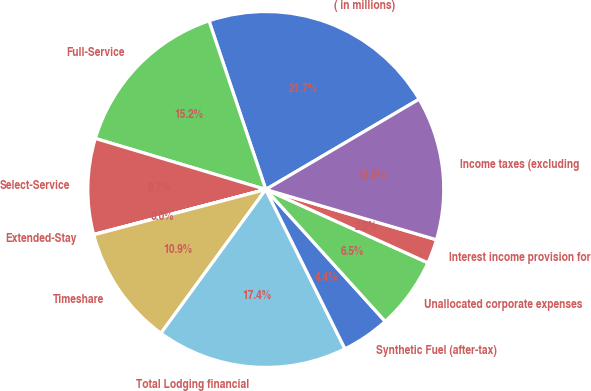Convert chart. <chart><loc_0><loc_0><loc_500><loc_500><pie_chart><fcel>( in millions)<fcel>Full-Service<fcel>Select-Service<fcel>Extended-Stay<fcel>Timeshare<fcel>Total Lodging financial<fcel>Synthetic Fuel (after-tax)<fcel>Unallocated corporate expenses<fcel>Interest income provision for<fcel>Income taxes (excluding<nl><fcel>21.7%<fcel>15.2%<fcel>8.7%<fcel>0.03%<fcel>10.87%<fcel>17.37%<fcel>4.37%<fcel>6.53%<fcel>2.2%<fcel>13.03%<nl></chart> 